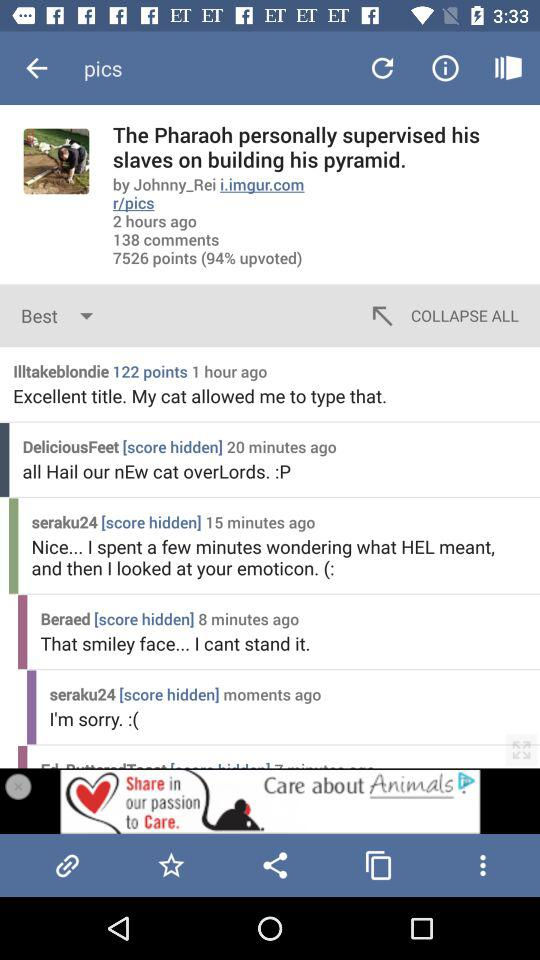How many comments are on the post?
Answer the question using a single word or phrase. 138 